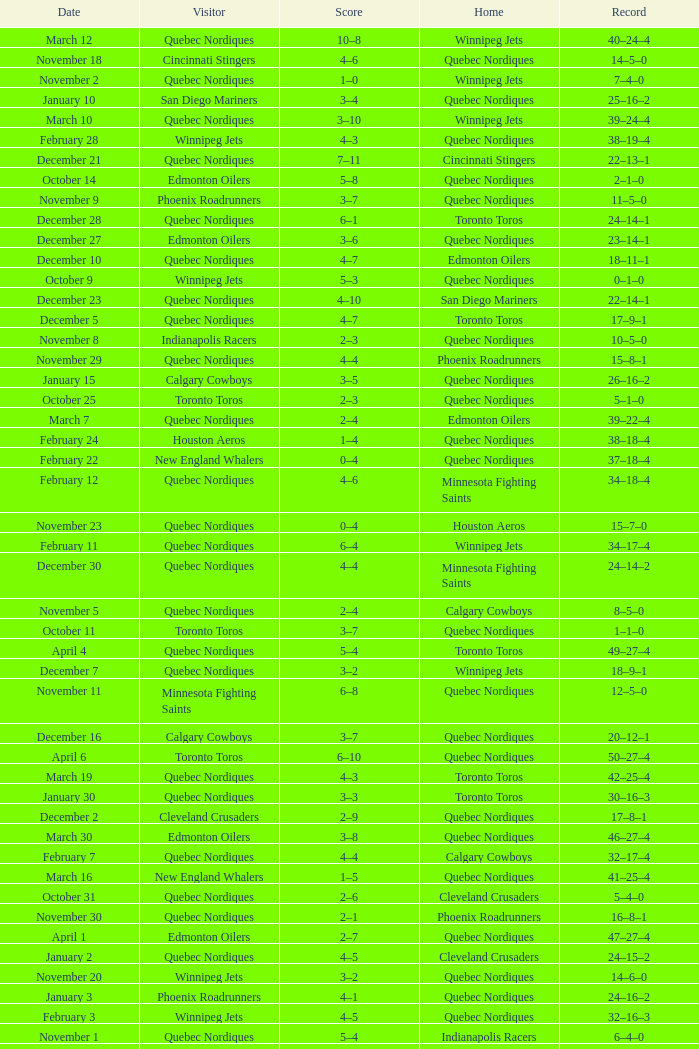What was the date of the game with a score of 2–1? November 30. Give me the full table as a dictionary. {'header': ['Date', 'Visitor', 'Score', 'Home', 'Record'], 'rows': [['March 12', 'Quebec Nordiques', '10–8', 'Winnipeg Jets', '40–24–4'], ['November 18', 'Cincinnati Stingers', '4–6', 'Quebec Nordiques', '14–5–0'], ['November 2', 'Quebec Nordiques', '1–0', 'Winnipeg Jets', '7–4–0'], ['January 10', 'San Diego Mariners', '3–4', 'Quebec Nordiques', '25–16–2'], ['March 10', 'Quebec Nordiques', '3–10', 'Winnipeg Jets', '39–24–4'], ['February 28', 'Winnipeg Jets', '4–3', 'Quebec Nordiques', '38–19–4'], ['December 21', 'Quebec Nordiques', '7–11', 'Cincinnati Stingers', '22–13–1'], ['October 14', 'Edmonton Oilers', '5–8', 'Quebec Nordiques', '2–1–0'], ['November 9', 'Phoenix Roadrunners', '3–7', 'Quebec Nordiques', '11–5–0'], ['December 28', 'Quebec Nordiques', '6–1', 'Toronto Toros', '24–14–1'], ['December 27', 'Edmonton Oilers', '3–6', 'Quebec Nordiques', '23–14–1'], ['December 10', 'Quebec Nordiques', '4–7', 'Edmonton Oilers', '18–11–1'], ['October 9', 'Winnipeg Jets', '5–3', 'Quebec Nordiques', '0–1–0'], ['December 23', 'Quebec Nordiques', '4–10', 'San Diego Mariners', '22–14–1'], ['December 5', 'Quebec Nordiques', '4–7', 'Toronto Toros', '17–9–1'], ['November 8', 'Indianapolis Racers', '2–3', 'Quebec Nordiques', '10–5–0'], ['November 29', 'Quebec Nordiques', '4–4', 'Phoenix Roadrunners', '15–8–1'], ['January 15', 'Calgary Cowboys', '3–5', 'Quebec Nordiques', '26–16–2'], ['October 25', 'Toronto Toros', '2–3', 'Quebec Nordiques', '5–1–0'], ['March 7', 'Quebec Nordiques', '2–4', 'Edmonton Oilers', '39–22–4'], ['February 24', 'Houston Aeros', '1–4', 'Quebec Nordiques', '38–18–4'], ['February 22', 'New England Whalers', '0–4', 'Quebec Nordiques', '37–18–4'], ['February 12', 'Quebec Nordiques', '4–6', 'Minnesota Fighting Saints', '34–18–4'], ['November 23', 'Quebec Nordiques', '0–4', 'Houston Aeros', '15–7–0'], ['February 11', 'Quebec Nordiques', '6–4', 'Winnipeg Jets', '34–17–4'], ['December 30', 'Quebec Nordiques', '4–4', 'Minnesota Fighting Saints', '24–14–2'], ['November 5', 'Quebec Nordiques', '2–4', 'Calgary Cowboys', '8–5–0'], ['October 11', 'Toronto Toros', '3–7', 'Quebec Nordiques', '1–1–0'], ['April 4', 'Quebec Nordiques', '5–4', 'Toronto Toros', '49–27–4'], ['December 7', 'Quebec Nordiques', '3–2', 'Winnipeg Jets', '18–9–1'], ['November 11', 'Minnesota Fighting Saints', '6–8', 'Quebec Nordiques', '12–5–0'], ['December 16', 'Calgary Cowboys', '3–7', 'Quebec Nordiques', '20–12–1'], ['April 6', 'Toronto Toros', '6–10', 'Quebec Nordiques', '50–27–4'], ['March 19', 'Quebec Nordiques', '4–3', 'Toronto Toros', '42–25–4'], ['January 30', 'Quebec Nordiques', '3–3', 'Toronto Toros', '30–16–3'], ['December 2', 'Cleveland Crusaders', '2–9', 'Quebec Nordiques', '17–8–1'], ['March 30', 'Edmonton Oilers', '3–8', 'Quebec Nordiques', '46–27–4'], ['February 7', 'Quebec Nordiques', '4–4', 'Calgary Cowboys', '32–17–4'], ['March 16', 'New England Whalers', '1–5', 'Quebec Nordiques', '41–25–4'], ['October 31', 'Quebec Nordiques', '2–6', 'Cleveland Crusaders', '5–4–0'], ['November 30', 'Quebec Nordiques', '2–1', 'Phoenix Roadrunners', '16–8–1'], ['April 1', 'Edmonton Oilers', '2–7', 'Quebec Nordiques', '47–27–4'], ['January 2', 'Quebec Nordiques', '4–5', 'Cleveland Crusaders', '24–15–2'], ['November 20', 'Winnipeg Jets', '3–2', 'Quebec Nordiques', '14–6–0'], ['January 3', 'Phoenix Roadrunners', '4–1', 'Quebec Nordiques', '24–16–2'], ['February 3', 'Winnipeg Jets', '4–5', 'Quebec Nordiques', '32–16–3'], ['November 1', 'Quebec Nordiques', '5–4', 'Indianapolis Racers', '6–4–0'], ['October 29', 'Quebec Nordiques', '2–4', 'New England Whalers', '5–3–0'], ['February 5', 'Quebec Nordiques', '2–4', 'Indianapolis Racers', '32–17–3'], ['February 15', 'Quebec Nordiques', '4–2', 'Houston Aeros', '35–18–4'], ['March 9', 'Quebec Nordiques', '4–7', 'Calgary Cowboys', '39–23–4'], ['October 18', 'Houston Aeros', '2–3', 'Quebec Nordiques', '3–1–0'], ['October 21', 'New England Whalers', '1–6', 'Quebec Nordiques', '4–1–0'], ['November 27', 'Quebec Nordiques', '1–5', 'San Diego Mariners', '15–8–0'], ['November 6', 'Quebec Nordiques', '5–3', 'Denver Spurs', '9–5–0'], ['January 25', 'Edmonton Oilers', '6–7', 'Quebec Nordiques', '29–16–2'], ['December 9', 'Quebec Nordiques', '1–4', 'Calgary Cowboys', '18–10–1'], ['March 27', 'Calgary Cowboys', '4–6', 'Quebec Nordiques', '45–27–4'], ['November 15', 'Quebec Nordiques', '3–1', 'New England Whalers', '13–5–0'], ['March 23', 'Cleveland Crusaders', '3–1', 'Quebec Nordiques', '43–27–4'], ['November 4', 'Quebec Nordiques', '4–3', 'Edmonton Oilers', '8–4–0'], ['January 27', 'Cincinnati Stingers', '1–9', 'Quebec Nordiques', '30–16–2'], ['March 2', 'Quebec Nordiques', '2–5', 'Toronto Toros', '38–20–4'], ['March 4', 'Quebec Nordiques', '1–4', 'Calgary Cowboys', '38–21–4'], ['January 17', 'Toronto Toros', '3–4', 'Quebec Nordiques', '27–16–2'], ['November 22', 'Quebec Nordiques', '9–6', 'Cincinnati Stingers', '15–6–0'], ['December 20', 'Calgary Flames', '7–8', 'Quebec Nordiques', '22–12–1'], ['February 17', 'San Diego Mariners', '2–5', 'Quebec Nordiques', '36–18–4'], ['January 21', 'Indianapolis Racers', '2–3', 'Quebec Nordiques', '28–16–2'], ['April 3', 'Toronto Toros', '1–5', 'Quebec Nordiques', '48–27–4'], ['January 31', 'Toronto Toros', '4–8', 'Quebec Nordiques', '31–16–3'], ['February 8', 'Quebec Nordiques', '5–4', 'Edmonton Oilers', '33–17–4'], ['March 25', 'Edmonton Oilers', '5–7', 'Quebec Nordiques', '44–27–4'], ['December 12', 'Quebec Nordiques', '4–6', 'Toronto Toros', '18–12–1'], ['March 14', 'Toronto Toros', '3–1', 'Quebec Nordiques', '40–25–4'], ['October 28', 'Quebec Nordiques', '2–5', 'Toronto Toros', '5–2–0'], ['March 21', 'Quebec Nordiques', '6–3', 'Edmonton Oilers', '43–26–4'], ['March 5', 'Quebec Nordiques', '5–4', 'Edmonton Oilers', '39–21–4'], ['March 20', 'Calgary Cowboys', '8–7', 'Quebec Nordiques', '42–26–4'], ['December 13', 'Toronto Toros', '3–6', 'Quebec Nordiques', '19–12–1'], ['December 18', 'Winnipeg Jets', '4–5', 'Quebec Nordiques', '21–12–1']]} 